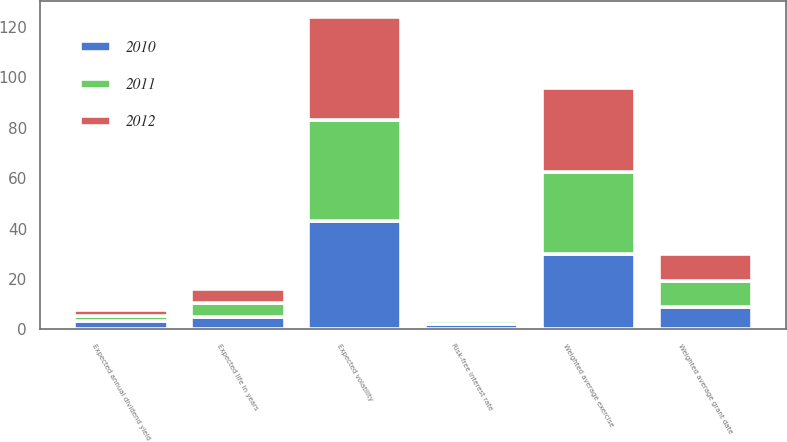Convert chart. <chart><loc_0><loc_0><loc_500><loc_500><stacked_bar_chart><ecel><fcel>Weighted average exercise<fcel>Expected annual dividend yield<fcel>Expected life in years<fcel>Expected volatility<fcel>Risk-free interest rate<fcel>Weighted average grant date<nl><fcel>2012<fcel>33.52<fcel>2.2<fcel>5.6<fcel>41<fcel>1.2<fcel>10.86<nl><fcel>2011<fcel>32.3<fcel>2.1<fcel>5.3<fcel>40<fcel>1.7<fcel>10.44<nl><fcel>2010<fcel>30<fcel>3.2<fcel>5.1<fcel>43<fcel>2.2<fcel>8.7<nl></chart> 